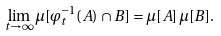Convert formula to latex. <formula><loc_0><loc_0><loc_500><loc_500>\lim _ { t \rightarrow \infty } \mu [ \varphi _ { t } ^ { - 1 } ( A ) \cap B ] = \mu [ A ] \, \mu [ B ] .</formula> 